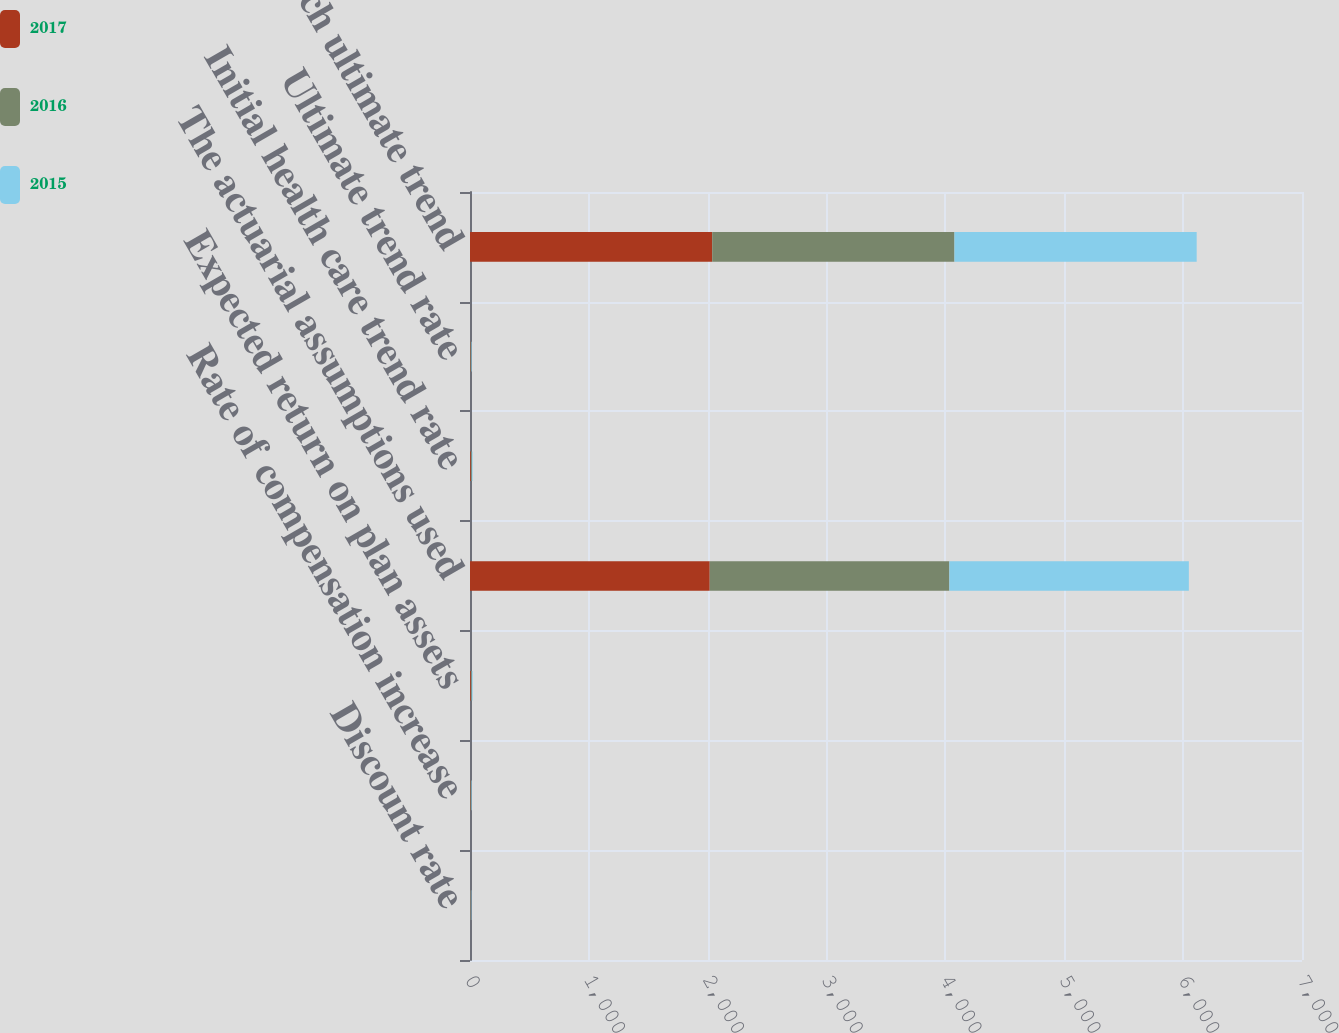Convert chart to OTSL. <chart><loc_0><loc_0><loc_500><loc_500><stacked_bar_chart><ecel><fcel>Discount rate<fcel>Rate of compensation increase<fcel>Expected return on plan assets<fcel>The actuarial assumptions used<fcel>Initial health care trend rate<fcel>Ultimate trend rate<fcel>Year in which ultimate trend<nl><fcel>2017<fcel>3.3<fcel>4.5<fcel>7.3<fcel>2017<fcel>7.3<fcel>4.5<fcel>2038<nl><fcel>2016<fcel>3.7<fcel>4.6<fcel>7.4<fcel>2016<fcel>7.7<fcel>4.5<fcel>2038<nl><fcel>2015<fcel>4.1<fcel>4.5<fcel>7.5<fcel>2015<fcel>6.7<fcel>4.5<fcel>2038<nl></chart> 